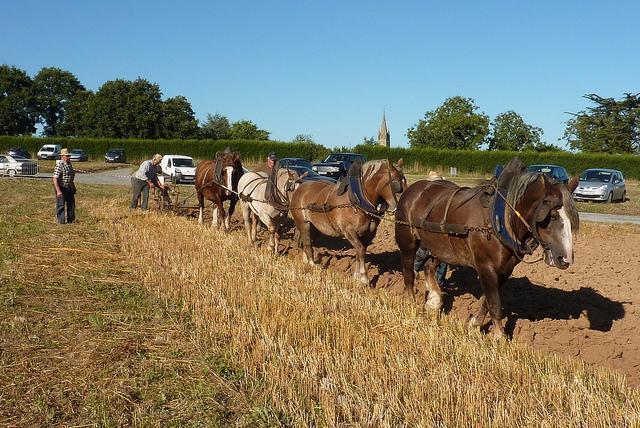How many bananas do you see?
Give a very brief answer. 0. 